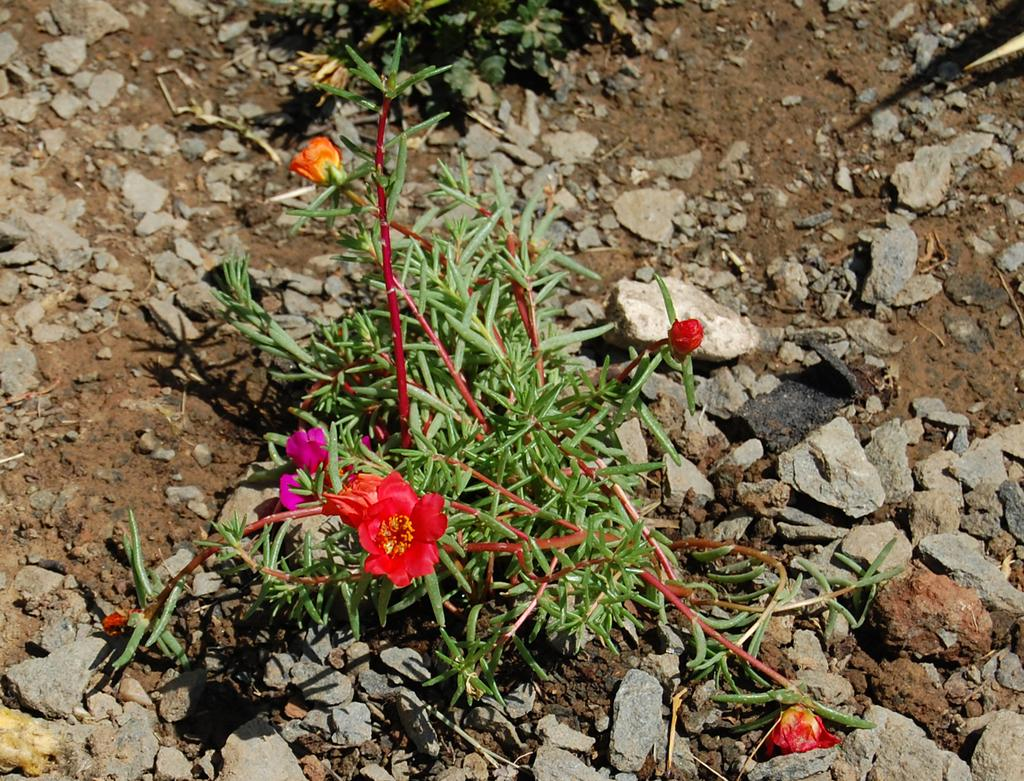What colors are the flowers in the image? The flowers in the image are in red and orange colors. What is located at the bottom of the image? There is a small plant at the bottom of the image. What can be seen on the ground in the image? There are rocks on the ground in the image. What type of pleasure can be seen enjoying the current in the image? There is no reference to pleasure or current in the image; it features flowers, a small plant, and rocks on the ground. Can you tell me how many jellyfish are swimming in the image? There are no jellyfish present in the image. 